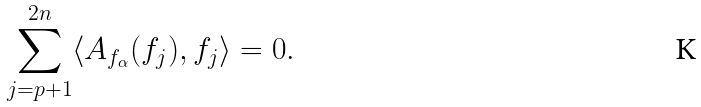Convert formula to latex. <formula><loc_0><loc_0><loc_500><loc_500>\sum _ { j = p + 1 } ^ { 2 n } \langle A _ { f _ { \alpha } } ( f _ { j } ) , f _ { j } \rangle = 0 .</formula> 